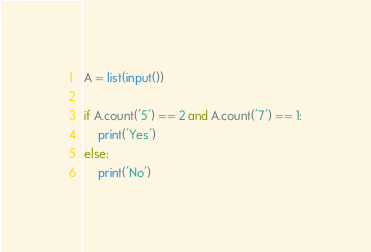Convert code to text. <code><loc_0><loc_0><loc_500><loc_500><_Python_>A = list(input())

if A.count('5') == 2 and A.count('7') == 1:
    print('Yes')
else:
    print('No')</code> 